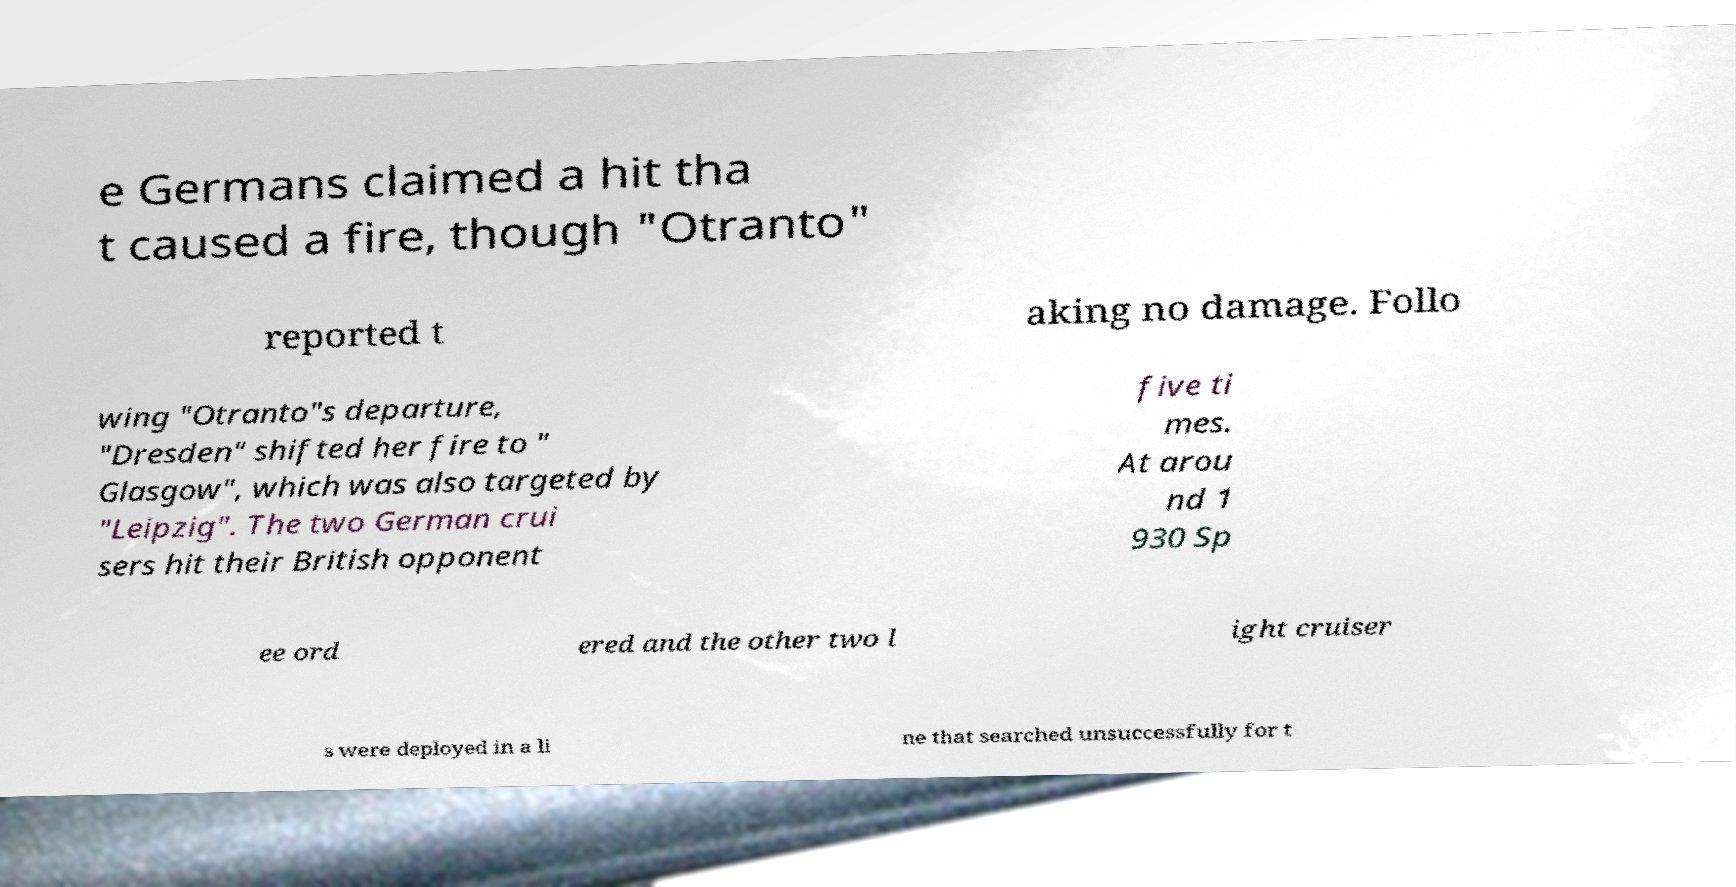Could you extract and type out the text from this image? e Germans claimed a hit tha t caused a fire, though "Otranto" reported t aking no damage. Follo wing "Otranto"s departure, "Dresden" shifted her fire to " Glasgow", which was also targeted by "Leipzig". The two German crui sers hit their British opponent five ti mes. At arou nd 1 930 Sp ee ord ered and the other two l ight cruiser s were deployed in a li ne that searched unsuccessfully for t 